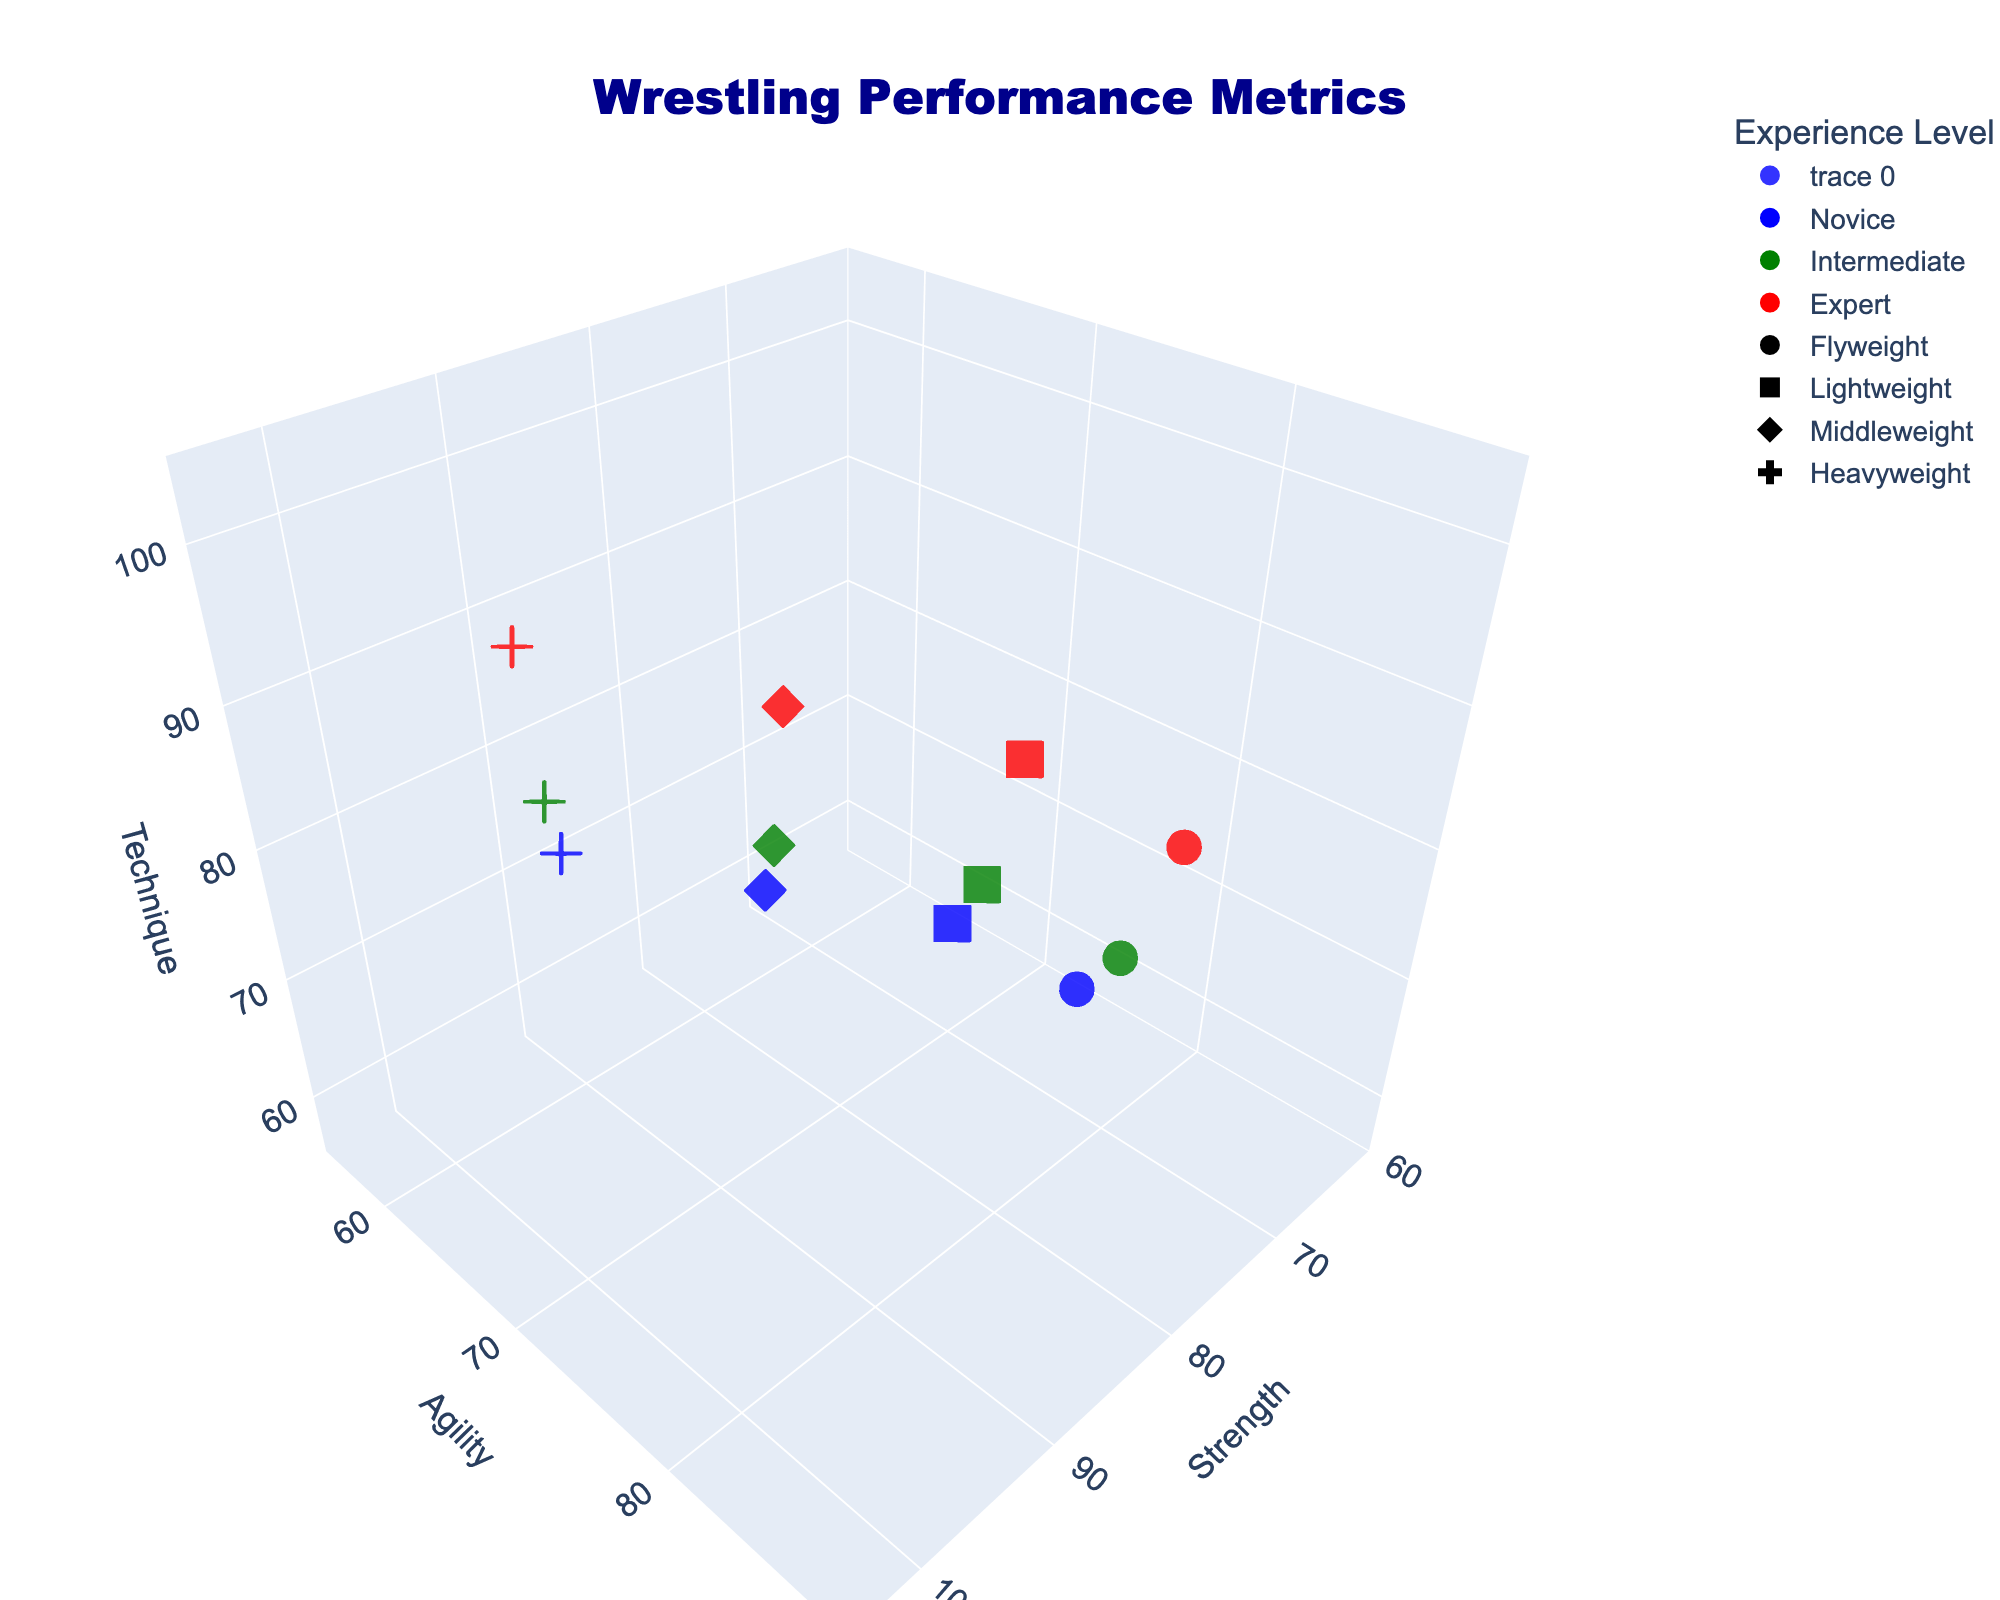What are the axes titles in the plot? The plot displays three axes, each representing a different wrestling performance metric: "Strength" on the x-axis, "Agility" on the y-axis, and "Technique" on the z-axis.
Answer: Strength, Agility, Technique How many data points are shown for the Flyweight category? There are three experience levels (Novice, Intermediate, Expert) within each weight class. Each weight class, including Flyweight, thus has 3 points corresponding to these experience levels.
Answer: 3 Which experience level has the highest technique value in the Heavyweight category? Looking at the markers for the Heavyweight category (represented by crosses) and identifying their colors, the highest technique value (z-axis) corresponds to the red marker, indicating an Expert experience level.
Answer: Expert What is the range of the Strength axis? The range of the Strength axis is visible from the axis tick labels on the figure. It starts at 60 and ends at 105, inclusive.
Answer: 60 to 105 Which weight classes are represented by circular markers? Circular markers correspond to the Flyweight category, as indicated by the legend or marker shape distinction in the plot.
Answer: Flyweight Is there any category or group with equal values for all three metrics? By looking at the 3D scatter plot, we notice that the Intermediate level in the Lightweight category (square green markers) has equal values: Strength = 75, Agility = 75, Technique = 75.
Answer: Yes, Lightweight Intermediate Compare the Strength for Novice and Expert levels in the Middleweight category. Which one is higher? Middleweight markers are diamonds, and comparing the blue (Novice) and red (Expert) markers shows that the Strength for Novice is 80, whereas for Expert it is 90. Thus, Expert has a higher Strength value.
Answer: Expert What is the average Agility value for the Intermediate experience level across all weight classes? Identify the green markers across all weight classes (one per each weight class). Their Agility values are Flyweight: 80, Lightweight: 75, Middleweight: 70, Heavyweight: 65. The average is calculated as (80+75+70+65) / 4 = 72.5.
Answer: 72.5 Which weight class has the lowest Strength value in the Expert experience level? Filtering the red markers for Expert experience, the Strength values are Flyweight: 75, Lightweight: 80, Middleweight: 90, Heavyweight: 100. The lowest among these is 75 in the Flyweight category.
Answer: Flyweight 